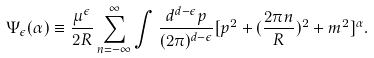Convert formula to latex. <formula><loc_0><loc_0><loc_500><loc_500>\Psi _ { \epsilon } ( \alpha ) \equiv \frac { \mu ^ { \epsilon } } { 2 R } \sum _ { n = - \infty } ^ { \infty } \int \frac { d ^ { d - \epsilon } p } { ( 2 \pi ) ^ { d - \epsilon } } [ p ^ { 2 } + ( \frac { 2 \pi n } { R } ) ^ { 2 } + m ^ { 2 } ] ^ { \alpha } .</formula> 